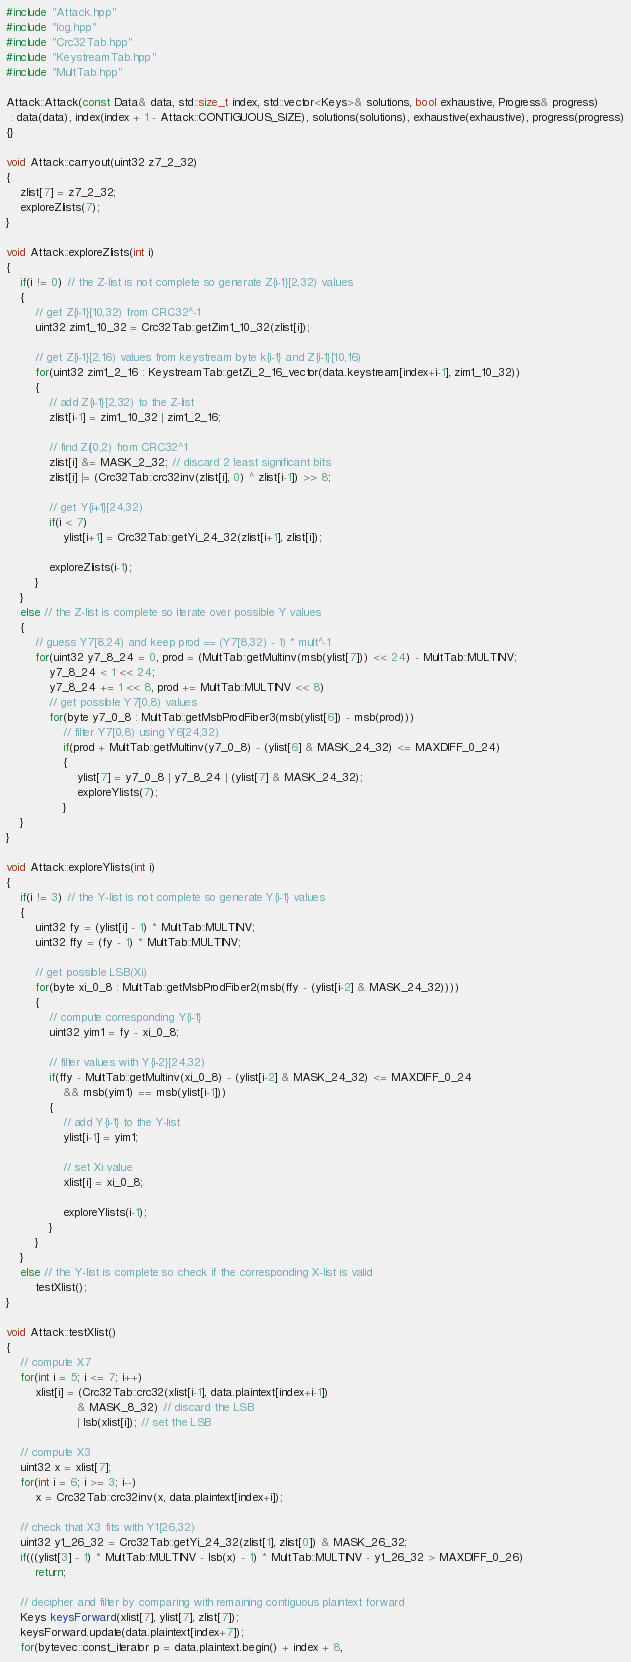<code> <loc_0><loc_0><loc_500><loc_500><_C++_>#include "Attack.hpp"
#include "log.hpp"
#include "Crc32Tab.hpp"
#include "KeystreamTab.hpp"
#include "MultTab.hpp"

Attack::Attack(const Data& data, std::size_t index, std::vector<Keys>& solutions, bool exhaustive, Progress& progress)
 : data(data), index(index + 1 - Attack::CONTIGUOUS_SIZE), solutions(solutions), exhaustive(exhaustive), progress(progress)
{}

void Attack::carryout(uint32 z7_2_32)
{
    zlist[7] = z7_2_32;
    exploreZlists(7);
}

void Attack::exploreZlists(int i)
{
    if(i != 0) // the Z-list is not complete so generate Z{i-1}[2,32) values
    {
        // get Z{i-1}[10,32) from CRC32^-1
        uint32 zim1_10_32 = Crc32Tab::getZim1_10_32(zlist[i]);

        // get Z{i-1}[2,16) values from keystream byte k{i-1} and Z{i-1}[10,16)
        for(uint32 zim1_2_16 : KeystreamTab::getZi_2_16_vector(data.keystream[index+i-1], zim1_10_32))
        {
            // add Z{i-1}[2,32) to the Z-list
            zlist[i-1] = zim1_10_32 | zim1_2_16;

            // find Zi[0,2) from CRC32^1
            zlist[i] &= MASK_2_32; // discard 2 least significant bits
            zlist[i] |= (Crc32Tab::crc32inv(zlist[i], 0) ^ zlist[i-1]) >> 8;

            // get Y{i+1}[24,32)
            if(i < 7)
                ylist[i+1] = Crc32Tab::getYi_24_32(zlist[i+1], zlist[i]);

            exploreZlists(i-1);
        }
    }
    else // the Z-list is complete so iterate over possible Y values
    {
        // guess Y7[8,24) and keep prod == (Y7[8,32) - 1) * mult^-1
        for(uint32 y7_8_24 = 0, prod = (MultTab::getMultinv(msb(ylist[7])) << 24) - MultTab::MULTINV;
            y7_8_24 < 1 << 24;
            y7_8_24 += 1 << 8, prod += MultTab::MULTINV << 8)
            // get possible Y7[0,8) values
            for(byte y7_0_8 : MultTab::getMsbProdFiber3(msb(ylist[6]) - msb(prod)))
                // filter Y7[0,8) using Y6[24,32)
                if(prod + MultTab::getMultinv(y7_0_8) - (ylist[6] & MASK_24_32) <= MAXDIFF_0_24)
                {
                    ylist[7] = y7_0_8 | y7_8_24 | (ylist[7] & MASK_24_32);
                    exploreYlists(7);
                }
    }
}

void Attack::exploreYlists(int i)
{
    if(i != 3) // the Y-list is not complete so generate Y{i-1} values
    {
        uint32 fy = (ylist[i] - 1) * MultTab::MULTINV;
        uint32 ffy = (fy - 1) * MultTab::MULTINV;

        // get possible LSB(Xi)
        for(byte xi_0_8 : MultTab::getMsbProdFiber2(msb(ffy - (ylist[i-2] & MASK_24_32))))
        {
            // compute corresponding Y{i-1}
            uint32 yim1 = fy - xi_0_8;

            // filter values with Y{i-2}[24,32)
            if(ffy - MultTab::getMultinv(xi_0_8) - (ylist[i-2] & MASK_24_32) <= MAXDIFF_0_24
                && msb(yim1) == msb(ylist[i-1]))
            {
                // add Y{i-1} to the Y-list
                ylist[i-1] = yim1;

                // set Xi value
                xlist[i] = xi_0_8;

                exploreYlists(i-1);
            }
        }
    }
    else // the Y-list is complete so check if the corresponding X-list is valid
        testXlist();
}

void Attack::testXlist()
{
    // compute X7
    for(int i = 5; i <= 7; i++)
        xlist[i] = (Crc32Tab::crc32(xlist[i-1], data.plaintext[index+i-1])
                    & MASK_8_32) // discard the LSB
                    | lsb(xlist[i]); // set the LSB

    // compute X3
    uint32 x = xlist[7];
    for(int i = 6; i >= 3; i--)
        x = Crc32Tab::crc32inv(x, data.plaintext[index+i]);

    // check that X3 fits with Y1[26,32)
    uint32 y1_26_32 = Crc32Tab::getYi_24_32(zlist[1], zlist[0]) & MASK_26_32;
    if(((ylist[3] - 1) * MultTab::MULTINV - lsb(x) - 1) * MultTab::MULTINV - y1_26_32 > MAXDIFF_0_26)
        return;

    // decipher and filter by comparing with remaining contiguous plaintext forward
    Keys keysForward(xlist[7], ylist[7], zlist[7]);
    keysForward.update(data.plaintext[index+7]);
    for(bytevec::const_iterator p = data.plaintext.begin() + index + 8,</code> 